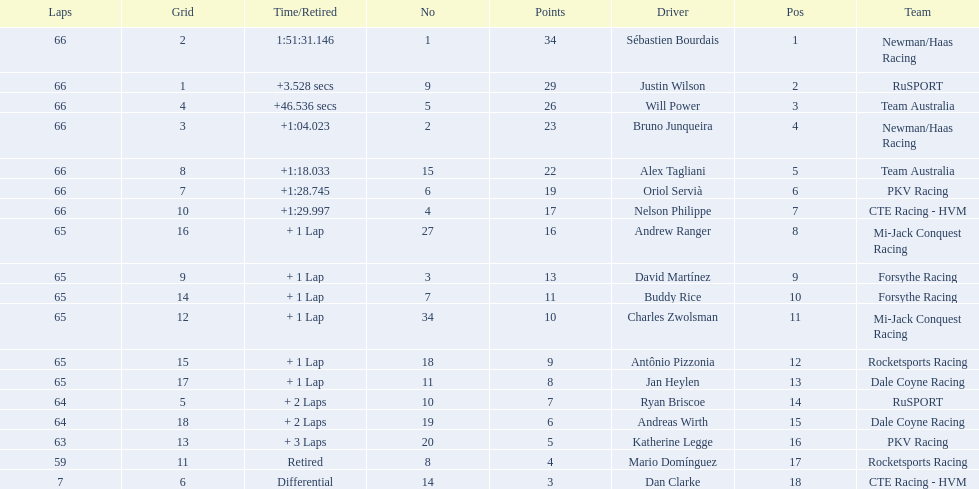Who are all of the 2006 gran premio telmex drivers? Sébastien Bourdais, Justin Wilson, Will Power, Bruno Junqueira, Alex Tagliani, Oriol Servià, Nelson Philippe, Andrew Ranger, David Martínez, Buddy Rice, Charles Zwolsman, Antônio Pizzonia, Jan Heylen, Ryan Briscoe, Andreas Wirth, Katherine Legge, Mario Domínguez, Dan Clarke. How many laps did they finish? 66, 66, 66, 66, 66, 66, 66, 65, 65, 65, 65, 65, 65, 64, 64, 63, 59, 7. What about just oriol servia and katherine legge? 66, 63. And which of those two drivers finished more laps? Oriol Servià. Could you help me parse every detail presented in this table? {'header': ['Laps', 'Grid', 'Time/Retired', 'No', 'Points', 'Driver', 'Pos', 'Team'], 'rows': [['66', '2', '1:51:31.146', '1', '34', 'Sébastien Bourdais', '1', 'Newman/Haas Racing'], ['66', '1', '+3.528 secs', '9', '29', 'Justin Wilson', '2', 'RuSPORT'], ['66', '4', '+46.536 secs', '5', '26', 'Will Power', '3', 'Team Australia'], ['66', '3', '+1:04.023', '2', '23', 'Bruno Junqueira', '4', 'Newman/Haas Racing'], ['66', '8', '+1:18.033', '15', '22', 'Alex Tagliani', '5', 'Team Australia'], ['66', '7', '+1:28.745', '6', '19', 'Oriol Servià', '6', 'PKV Racing'], ['66', '10', '+1:29.997', '4', '17', 'Nelson Philippe', '7', 'CTE Racing - HVM'], ['65', '16', '+ 1 Lap', '27', '16', 'Andrew Ranger', '8', 'Mi-Jack Conquest Racing'], ['65', '9', '+ 1 Lap', '3', '13', 'David Martínez', '9', 'Forsythe Racing'], ['65', '14', '+ 1 Lap', '7', '11', 'Buddy Rice', '10', 'Forsythe Racing'], ['65', '12', '+ 1 Lap', '34', '10', 'Charles Zwolsman', '11', 'Mi-Jack Conquest Racing'], ['65', '15', '+ 1 Lap', '18', '9', 'Antônio Pizzonia', '12', 'Rocketsports Racing'], ['65', '17', '+ 1 Lap', '11', '8', 'Jan Heylen', '13', 'Dale Coyne Racing'], ['64', '5', '+ 2 Laps', '10', '7', 'Ryan Briscoe', '14', 'RuSPORT'], ['64', '18', '+ 2 Laps', '19', '6', 'Andreas Wirth', '15', 'Dale Coyne Racing'], ['63', '13', '+ 3 Laps', '20', '5', 'Katherine Legge', '16', 'PKV Racing'], ['59', '11', 'Retired', '8', '4', 'Mario Domínguez', '17', 'Rocketsports Racing'], ['7', '6', 'Differential', '14', '3', 'Dan Clarke', '18', 'CTE Racing - HVM']]} 